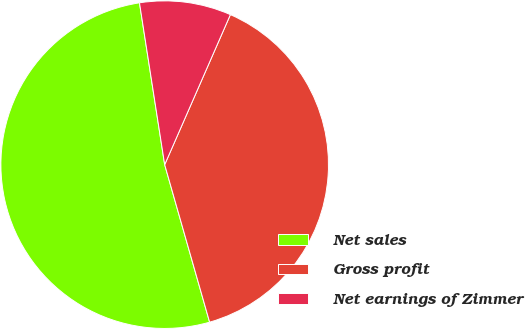Convert chart. <chart><loc_0><loc_0><loc_500><loc_500><pie_chart><fcel>Net sales<fcel>Gross profit<fcel>Net earnings of Zimmer<nl><fcel>51.97%<fcel>39.01%<fcel>9.03%<nl></chart> 